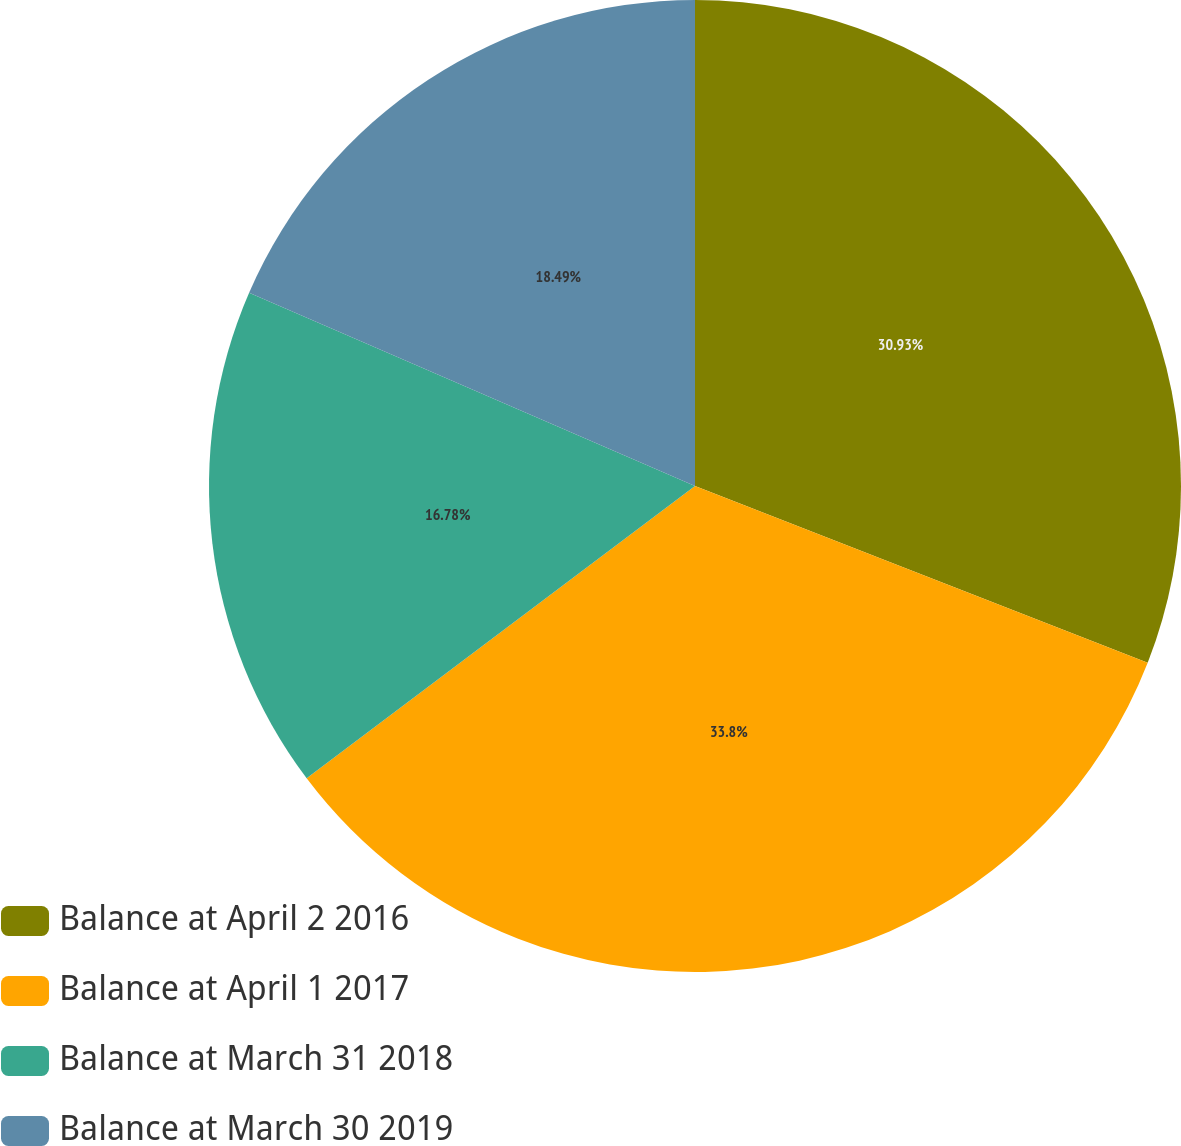Convert chart to OTSL. <chart><loc_0><loc_0><loc_500><loc_500><pie_chart><fcel>Balance at April 2 2016<fcel>Balance at April 1 2017<fcel>Balance at March 31 2018<fcel>Balance at March 30 2019<nl><fcel>30.93%<fcel>33.81%<fcel>16.78%<fcel>18.49%<nl></chart> 